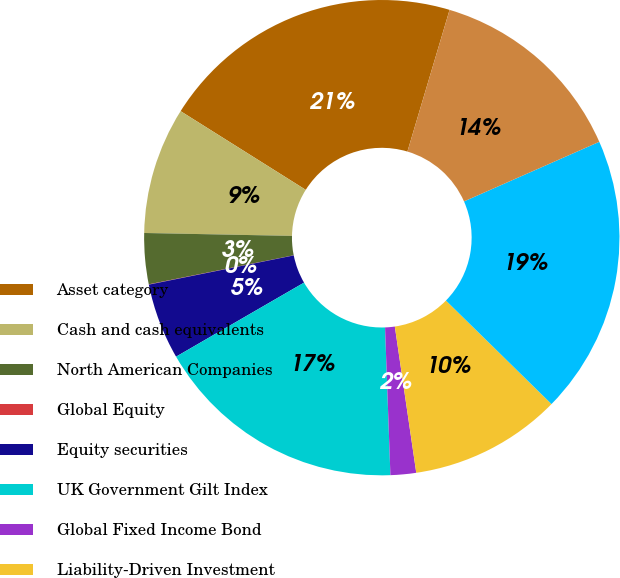Convert chart. <chart><loc_0><loc_0><loc_500><loc_500><pie_chart><fcel>Asset category<fcel>Cash and cash equivalents<fcel>North American Companies<fcel>Global Equity<fcel>Equity securities<fcel>UK Government Gilt Index<fcel>Global Fixed Income Bond<fcel>Liability-Driven Investment<fcel>Fixed income<fcel>Multi-asset<nl><fcel>20.67%<fcel>8.62%<fcel>3.46%<fcel>0.02%<fcel>5.18%<fcel>17.23%<fcel>1.74%<fcel>10.34%<fcel>18.95%<fcel>13.79%<nl></chart> 